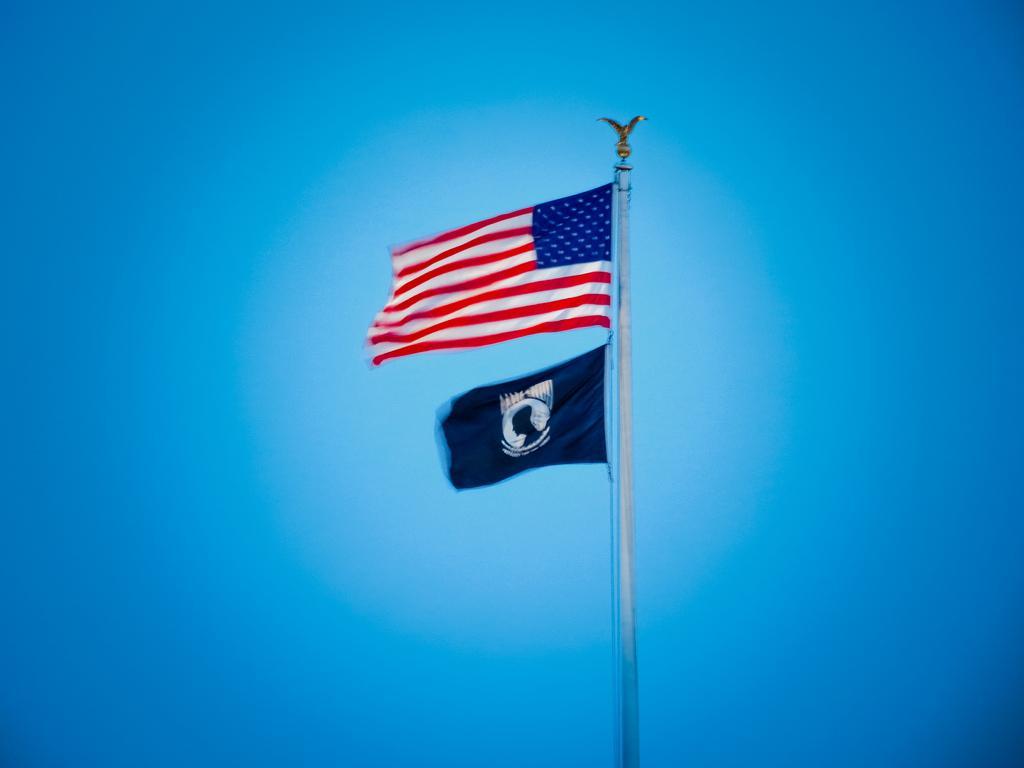Could you give a brief overview of what you see in this image? This image consists of flags which are in the center. 